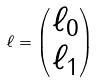<formula> <loc_0><loc_0><loc_500><loc_500>\ell = \begin{pmatrix} \ell _ { 0 } \\ \ell _ { 1 } \end{pmatrix}</formula> 